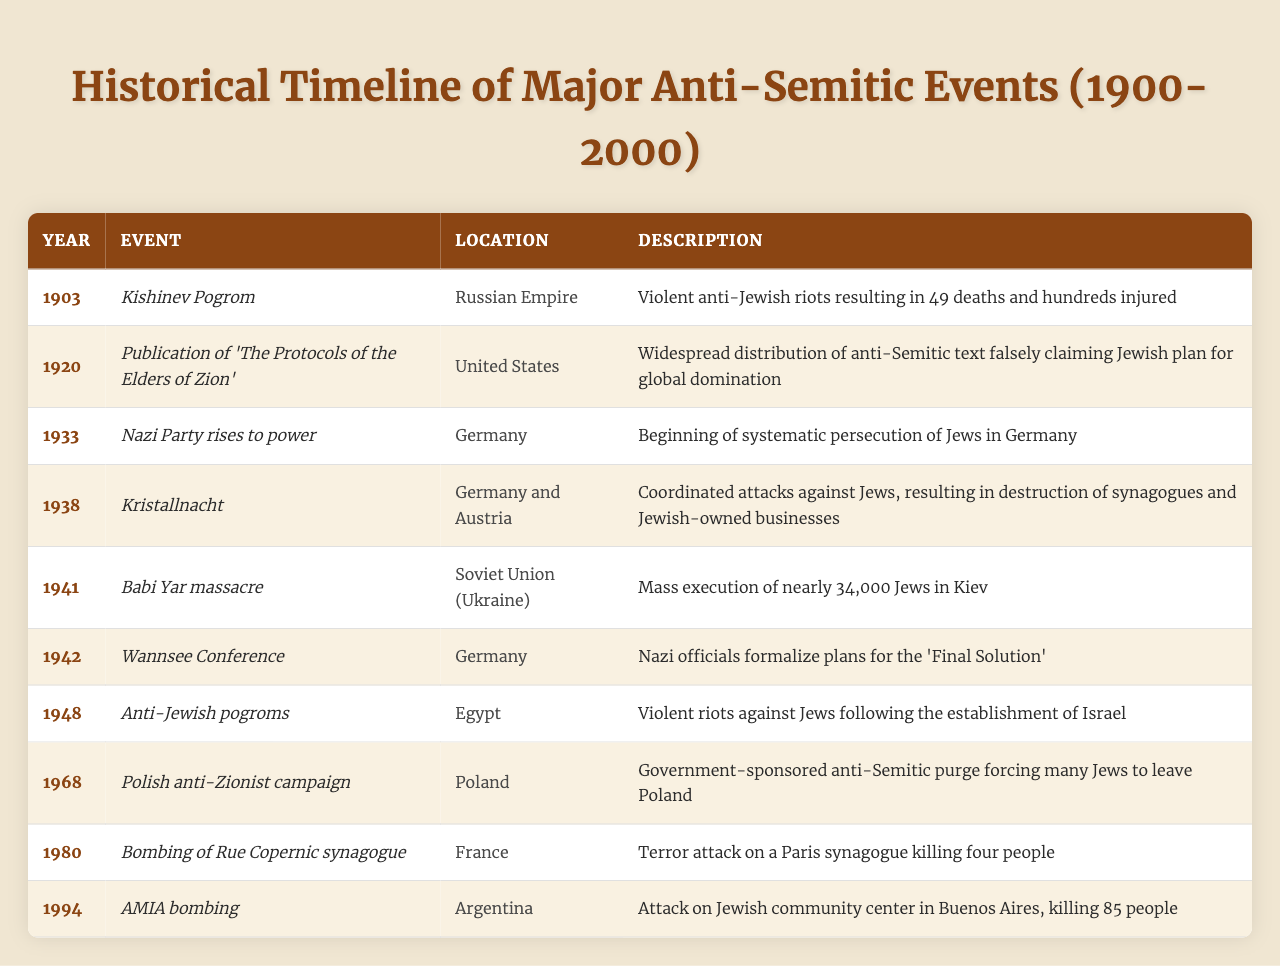What event occurred in 1938? The table lists "Kristallnacht" as the event that occurred in 1938, along with its associated details.
Answer: Kristallnacht Which location experienced the Babi Yar massacre? The table specifies that the Babi Yar massacre took place in the Soviet Union (Ukraine), making it easy to identify the location.
Answer: Soviet Union (Ukraine) How many deaths were reported during the Kishinev Pogrom? The table indicates that the Kishinev Pogrom resulted in 49 deaths, which is a specific fact easily retrieved from the data.
Answer: 49 What year did the Nazi Party rise to power? According to the table, this event is recorded in 1933, making it a straightforward retrieval question at a specified time.
Answer: 1933 Was the publication of "The Protocols of the Elders of Zion" associated with anti-Semitism? The table provides a description stating that it falsely claimed a Jewish plan for global domination, confirming its anti-Semitic nature.
Answer: Yes How many years passed between the Kishinev Pogrom and Kristallnacht? To find this, subtract the years: 1938 - 1903 = 35 years, showing the time interval between the two events in the timeline.
Answer: 35 years List all the major anti-Semitic events in Germany from the given table. The table shows three events in Germany: the Nazi Party rise in 1933, Kristallnacht in 1938, and the Wannsee Conference in 1942.
Answer: Nazi Party rise, Kristallnacht, Wannsee Conference Which event had the highest death toll listed in the table? The Babi Yar massacre in 1941 had nearly 34,000 Jewish deaths, significantly more than any other event mentioned in the timeline.
Answer: Babi Yar massacre What was a result of the Polish anti-Zionist campaign in 1968? According to the table, the campaign led to a government-sponsored anti-Semitic purge that forced many Jews to leave Poland, indicating a significant outcome of that event.
Answer: Anti-Semitic purge prompting Jewish emigration Which event occurred most recently in the table? The AMIA bombing is the last event chronologically listed in the table, making it the most recent incident of those documented.
Answer: AMIA bombing 